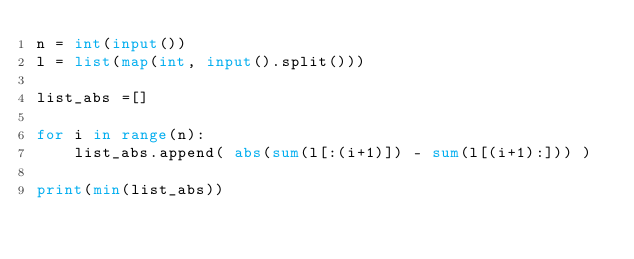<code> <loc_0><loc_0><loc_500><loc_500><_Python_>n = int(input())
l = list(map(int, input().split()))

list_abs =[]

for i in range(n):
    list_abs.append( abs(sum(l[:(i+1)]) - sum(l[(i+1):])) )

print(min(list_abs))</code> 